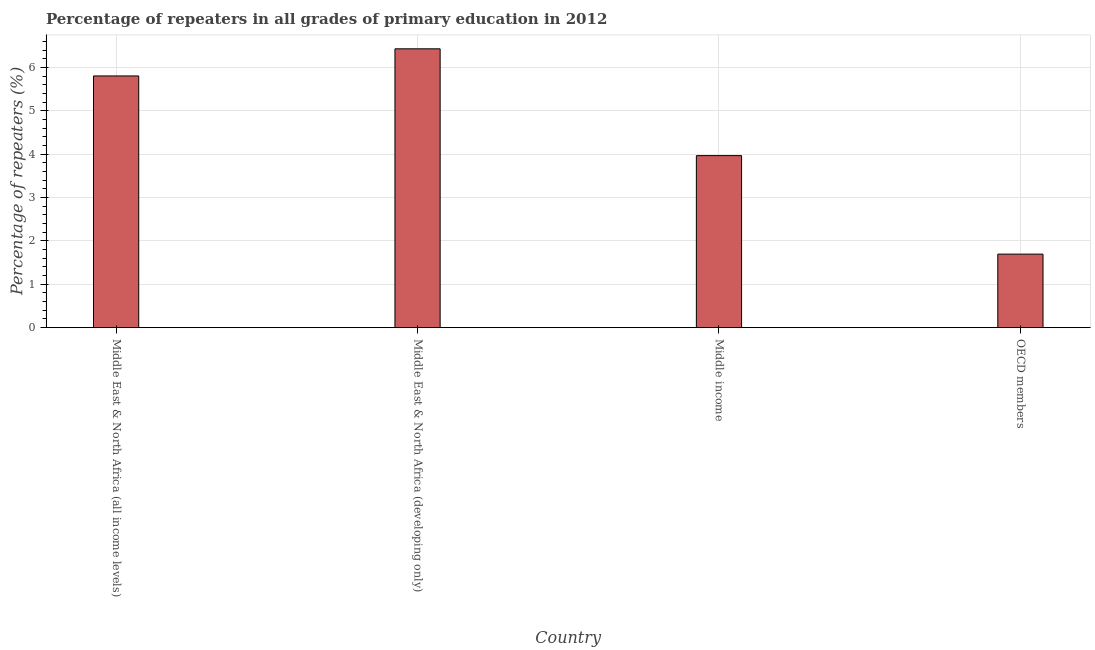Does the graph contain grids?
Provide a succinct answer. Yes. What is the title of the graph?
Give a very brief answer. Percentage of repeaters in all grades of primary education in 2012. What is the label or title of the X-axis?
Give a very brief answer. Country. What is the label or title of the Y-axis?
Give a very brief answer. Percentage of repeaters (%). What is the percentage of repeaters in primary education in Middle income?
Your response must be concise. 3.97. Across all countries, what is the maximum percentage of repeaters in primary education?
Offer a very short reply. 6.43. Across all countries, what is the minimum percentage of repeaters in primary education?
Make the answer very short. 1.7. In which country was the percentage of repeaters in primary education maximum?
Keep it short and to the point. Middle East & North Africa (developing only). In which country was the percentage of repeaters in primary education minimum?
Provide a succinct answer. OECD members. What is the sum of the percentage of repeaters in primary education?
Provide a succinct answer. 17.89. What is the difference between the percentage of repeaters in primary education in Middle East & North Africa (developing only) and OECD members?
Offer a very short reply. 4.73. What is the average percentage of repeaters in primary education per country?
Provide a succinct answer. 4.47. What is the median percentage of repeaters in primary education?
Your response must be concise. 4.88. In how many countries, is the percentage of repeaters in primary education greater than 3.8 %?
Offer a very short reply. 3. What is the ratio of the percentage of repeaters in primary education in Middle East & North Africa (all income levels) to that in OECD members?
Offer a terse response. 3.42. Is the sum of the percentage of repeaters in primary education in Middle East & North Africa (developing only) and Middle income greater than the maximum percentage of repeaters in primary education across all countries?
Make the answer very short. Yes. What is the difference between the highest and the lowest percentage of repeaters in primary education?
Provide a succinct answer. 4.73. How many bars are there?
Your response must be concise. 4. Are all the bars in the graph horizontal?
Give a very brief answer. No. How many countries are there in the graph?
Make the answer very short. 4. Are the values on the major ticks of Y-axis written in scientific E-notation?
Your answer should be very brief. No. What is the Percentage of repeaters (%) of Middle East & North Africa (all income levels)?
Provide a short and direct response. 5.8. What is the Percentage of repeaters (%) in Middle East & North Africa (developing only)?
Provide a succinct answer. 6.43. What is the Percentage of repeaters (%) of Middle income?
Offer a terse response. 3.97. What is the Percentage of repeaters (%) of OECD members?
Your answer should be very brief. 1.7. What is the difference between the Percentage of repeaters (%) in Middle East & North Africa (all income levels) and Middle East & North Africa (developing only)?
Provide a short and direct response. -0.63. What is the difference between the Percentage of repeaters (%) in Middle East & North Africa (all income levels) and Middle income?
Ensure brevity in your answer.  1.84. What is the difference between the Percentage of repeaters (%) in Middle East & North Africa (all income levels) and OECD members?
Offer a very short reply. 4.11. What is the difference between the Percentage of repeaters (%) in Middle East & North Africa (developing only) and Middle income?
Offer a very short reply. 2.46. What is the difference between the Percentage of repeaters (%) in Middle East & North Africa (developing only) and OECD members?
Provide a short and direct response. 4.73. What is the difference between the Percentage of repeaters (%) in Middle income and OECD members?
Your answer should be very brief. 2.27. What is the ratio of the Percentage of repeaters (%) in Middle East & North Africa (all income levels) to that in Middle East & North Africa (developing only)?
Make the answer very short. 0.9. What is the ratio of the Percentage of repeaters (%) in Middle East & North Africa (all income levels) to that in Middle income?
Ensure brevity in your answer.  1.46. What is the ratio of the Percentage of repeaters (%) in Middle East & North Africa (all income levels) to that in OECD members?
Keep it short and to the point. 3.42. What is the ratio of the Percentage of repeaters (%) in Middle East & North Africa (developing only) to that in Middle income?
Provide a succinct answer. 1.62. What is the ratio of the Percentage of repeaters (%) in Middle East & North Africa (developing only) to that in OECD members?
Your response must be concise. 3.79. What is the ratio of the Percentage of repeaters (%) in Middle income to that in OECD members?
Offer a terse response. 2.34. 